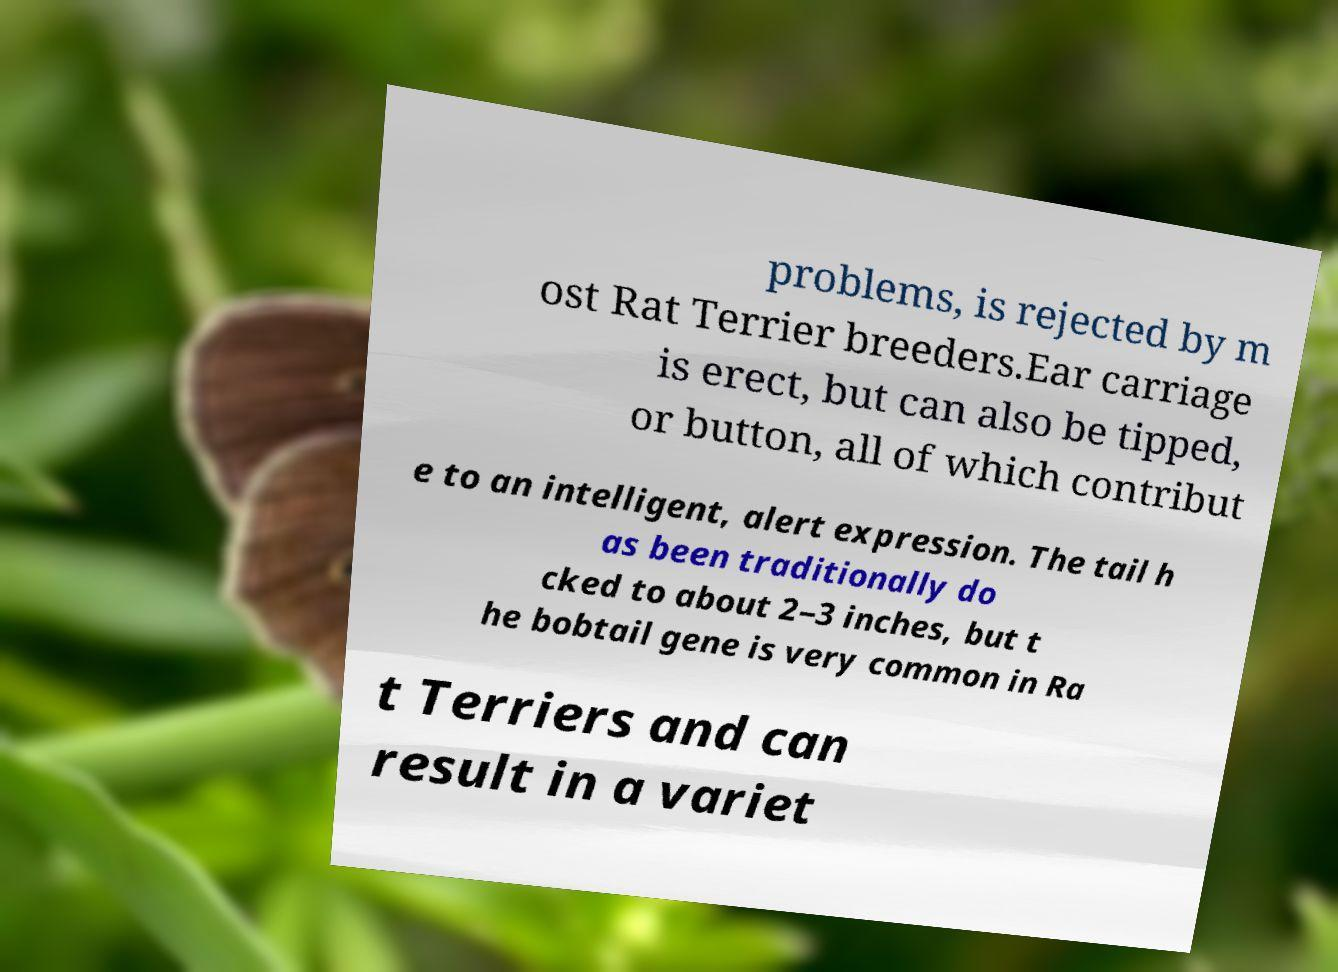I need the written content from this picture converted into text. Can you do that? problems, is rejected by m ost Rat Terrier breeders.Ear carriage is erect, but can also be tipped, or button, all of which contribut e to an intelligent, alert expression. The tail h as been traditionally do cked to about 2–3 inches, but t he bobtail gene is very common in Ra t Terriers and can result in a variet 